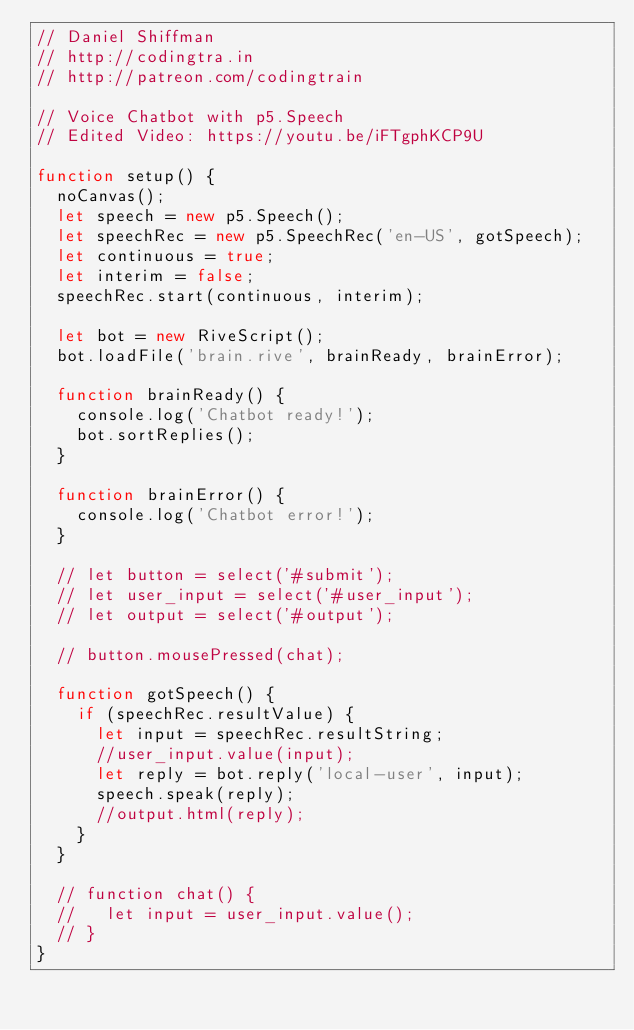<code> <loc_0><loc_0><loc_500><loc_500><_JavaScript_>// Daniel Shiffman
// http://codingtra.in
// http://patreon.com/codingtrain

// Voice Chatbot with p5.Speech
// Edited Video: https://youtu.be/iFTgphKCP9U

function setup() {
  noCanvas();
  let speech = new p5.Speech();
  let speechRec = new p5.SpeechRec('en-US', gotSpeech);
  let continuous = true;
  let interim = false;
  speechRec.start(continuous, interim);

  let bot = new RiveScript();
  bot.loadFile('brain.rive', brainReady, brainError);

  function brainReady() {
    console.log('Chatbot ready!');
    bot.sortReplies();
  }

  function brainError() {
    console.log('Chatbot error!');
  }

  // let button = select('#submit');
  // let user_input = select('#user_input');
  // let output = select('#output');

  // button.mousePressed(chat);

  function gotSpeech() {
    if (speechRec.resultValue) {
      let input = speechRec.resultString;
      //user_input.value(input);
      let reply = bot.reply('local-user', input);
      speech.speak(reply);
      //output.html(reply);
    }
  }

  // function chat() {
  //   let input = user_input.value();
  // }
}
</code> 